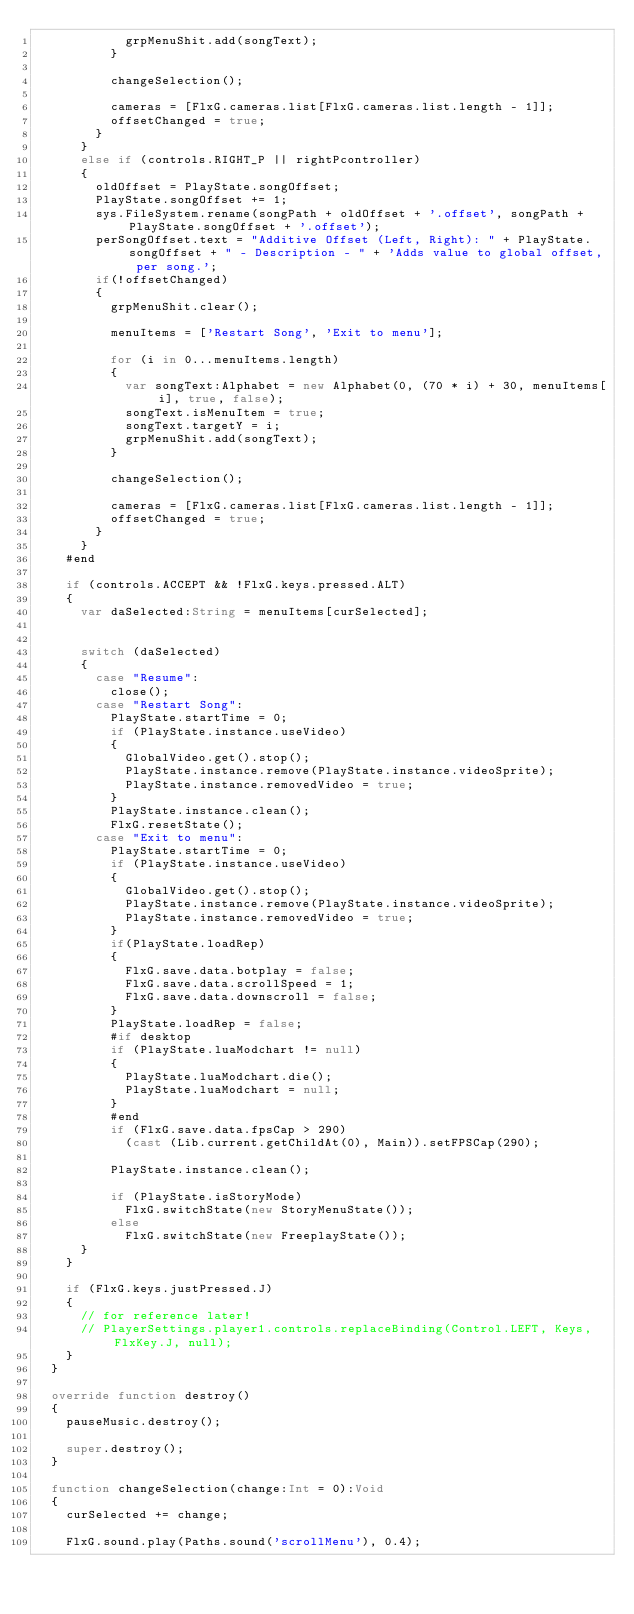Convert code to text. <code><loc_0><loc_0><loc_500><loc_500><_Haxe_>						grpMenuShit.add(songText);
					}

					changeSelection();

					cameras = [FlxG.cameras.list[FlxG.cameras.list.length - 1]];
					offsetChanged = true;
				}
			} 
			else if (controls.RIGHT_P || rightPcontroller)
			{
				oldOffset = PlayState.songOffset;
				PlayState.songOffset += 1;
				sys.FileSystem.rename(songPath + oldOffset + '.offset', songPath + PlayState.songOffset + '.offset');
				perSongOffset.text = "Additive Offset (Left, Right): " + PlayState.songOffset + " - Description - " + 'Adds value to global offset, per song.';
				if(!offsetChanged)
				{
					grpMenuShit.clear();

					menuItems = ['Restart Song', 'Exit to menu'];

					for (i in 0...menuItems.length)
					{
						var songText:Alphabet = new Alphabet(0, (70 * i) + 30, menuItems[i], true, false);
						songText.isMenuItem = true;
						songText.targetY = i;
						grpMenuShit.add(songText);
					}

					changeSelection();

					cameras = [FlxG.cameras.list[FlxG.cameras.list.length - 1]];
					offsetChanged = true;
				}
			}
		#end

		if (controls.ACCEPT && !FlxG.keys.pressed.ALT)
		{
			var daSelected:String = menuItems[curSelected];

			
			switch (daSelected)
			{
				case "Resume":
					close();
				case "Restart Song":
					PlayState.startTime = 0;
					if (PlayState.instance.useVideo)
					{
						GlobalVideo.get().stop();
						PlayState.instance.remove(PlayState.instance.videoSprite);
						PlayState.instance.removedVideo = true;
					}
					PlayState.instance.clean();
					FlxG.resetState();
				case "Exit to menu":
					PlayState.startTime = 0;
					if (PlayState.instance.useVideo)
					{
						GlobalVideo.get().stop();
						PlayState.instance.remove(PlayState.instance.videoSprite);
						PlayState.instance.removedVideo = true;
					}
					if(PlayState.loadRep)
					{
						FlxG.save.data.botplay = false;
						FlxG.save.data.scrollSpeed = 1;
						FlxG.save.data.downscroll = false;
					}
					PlayState.loadRep = false;
					#if desktop
					if (PlayState.luaModchart != null)
					{
						PlayState.luaModchart.die();
						PlayState.luaModchart = null;
					}
					#end
					if (FlxG.save.data.fpsCap > 290)
						(cast (Lib.current.getChildAt(0), Main)).setFPSCap(290);
					
					PlayState.instance.clean();

					if (PlayState.isStoryMode)
						FlxG.switchState(new StoryMenuState());
					else
						FlxG.switchState(new FreeplayState());
			}
		}

		if (FlxG.keys.justPressed.J)
		{
			// for reference later!
			// PlayerSettings.player1.controls.replaceBinding(Control.LEFT, Keys, FlxKey.J, null);
		}
	}

	override function destroy()
	{
		pauseMusic.destroy();

		super.destroy();
	}

	function changeSelection(change:Int = 0):Void
	{
		curSelected += change;
		
		FlxG.sound.play(Paths.sound('scrollMenu'), 0.4);
</code> 